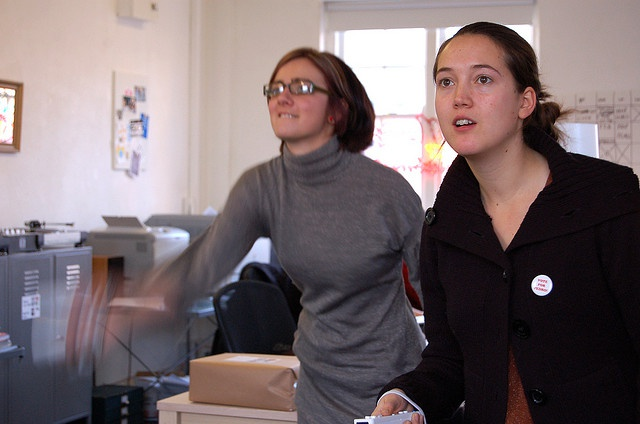Describe the objects in this image and their specific colors. I can see people in tan, black, brown, salmon, and maroon tones, people in tan, gray, black, and brown tones, chair in tan, black, and gray tones, chair in tan, black, and gray tones, and remote in tan, darkgray, lavender, brown, and gray tones in this image. 